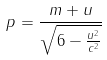Convert formula to latex. <formula><loc_0><loc_0><loc_500><loc_500>p = \frac { m + u } { \sqrt { 6 - \frac { u ^ { 2 } } { c ^ { 2 } } } }</formula> 